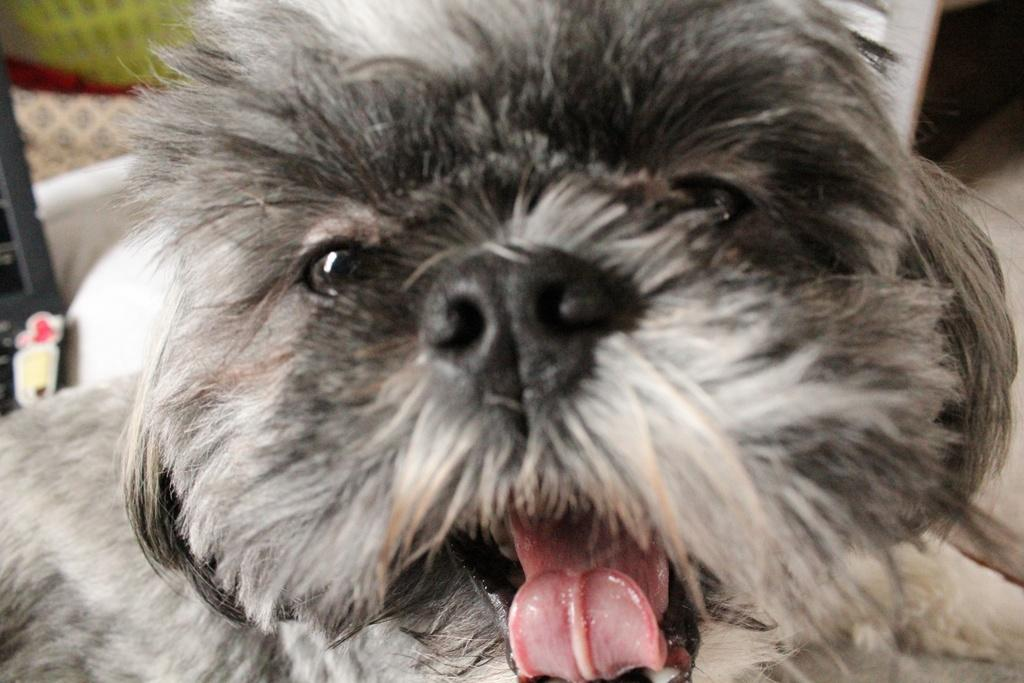What type of animal is in the image? There is a dog in the image. Can you describe the dog's coloring? The dog has black, white, and brown colors. What can be observed about the background of the image? The background of the image is blurred. What type of wilderness can be seen in the background of the image? There is no wilderness visible in the image, as the background is blurred. How many weeks has the dog been training for the bomb disposal unit? There is no information about the dog's training or involvement in a bomb disposal unit in the image. 